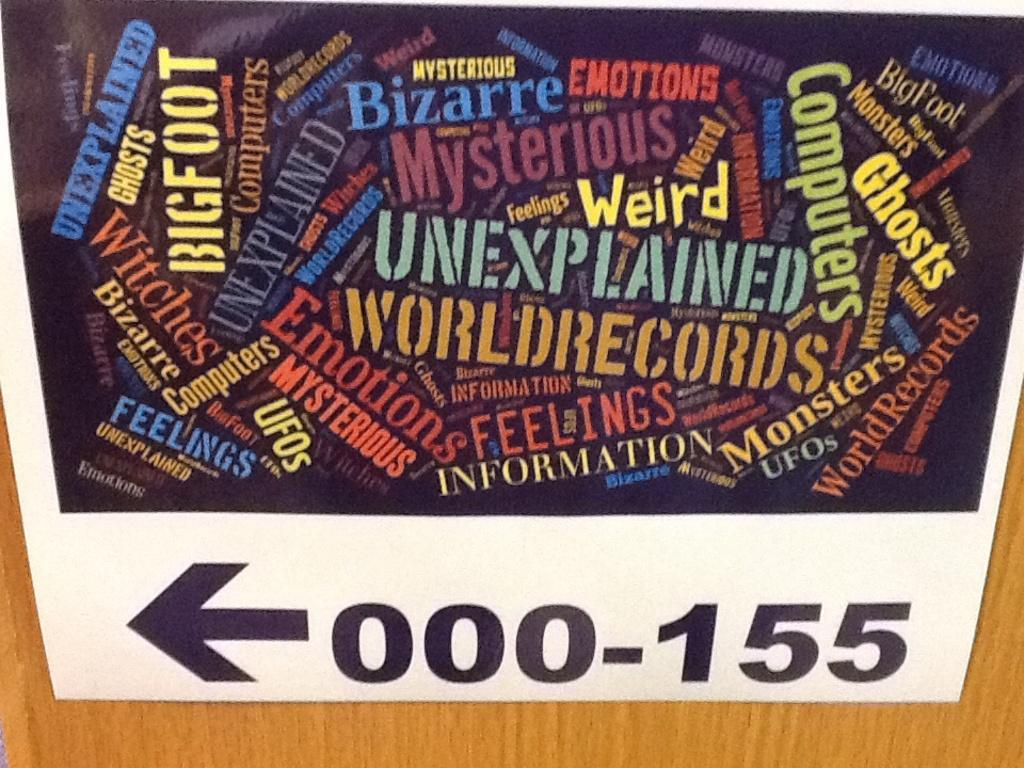<image>
Write a terse but informative summary of the picture. A sign shows that categories such as "unexplained, emotions, UFOs, and bigfoot are in sections 000-155 to the left. 